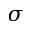<formula> <loc_0><loc_0><loc_500><loc_500>\sigma</formula> 